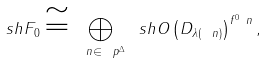Convert formula to latex. <formula><loc_0><loc_0><loc_500><loc_500>\ s h { F } _ { 0 } \cong \bigoplus _ { \ n \in \ p ^ { \Delta } } \ s h { O } \left ( D _ { \lambda ( \ n ) } \right ) ^ { f ^ { 0 } _ { \ } n } ,</formula> 